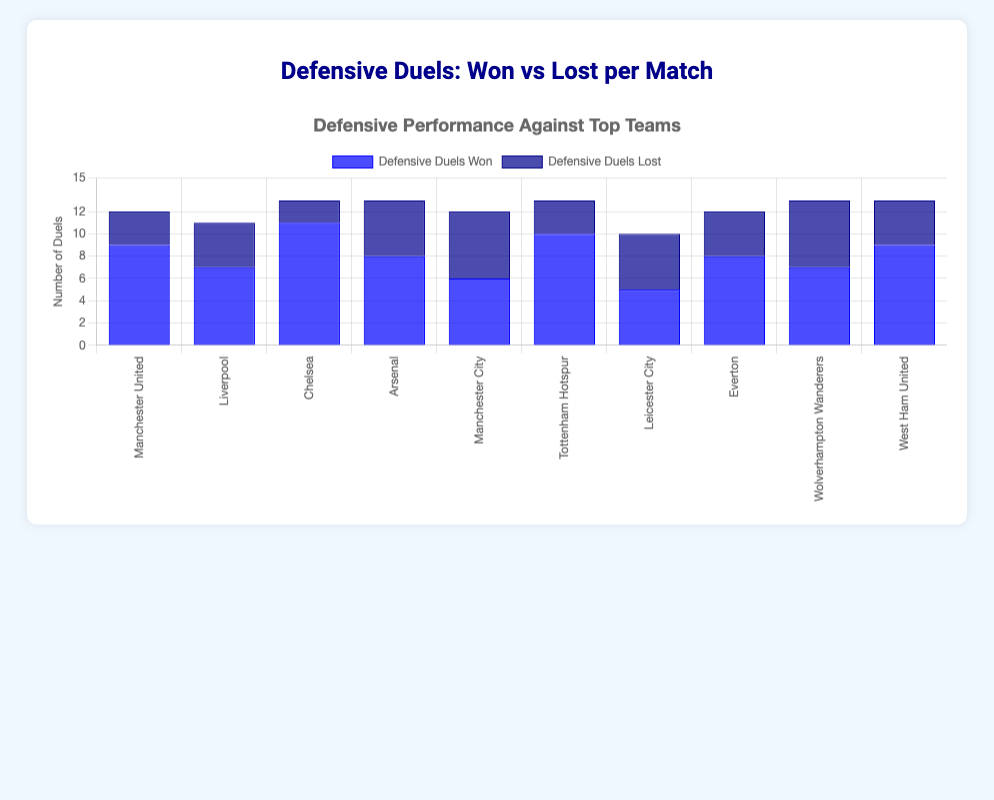Which match had the highest number of defensive duels won? By observing the height of the light blue bars representing the 'Defensive Duels Won' across all matches, the tallest bar indicates the highest number. The match against Chelsea has the highest bar.
Answer: Chelsea What is the total number of defensive duels lost across all matches? Sum the values of all the dark blue bars (representing 'Defensive Duels Lost'): 3 + 4 + 2 + 5 + 6 + 3 + 5 + 4 + 6 + 4 = 42.
Answer: 42 Which team had an equal number of defensive duels won and lost? Check the bars where the heights of dark blue and light blue bars are equal. This occurs for the match against Manchester City and Leicester City.
Answer: Manchester City, Leicester City How many more defensive duels were won than lost in the match against Arsenal? Identify the bars for Arsenal: 'Defensive Duels Won' is 8 and 'Defensive Duels Lost' is 5. Calculate the difference: 8 - 5 = 3.
Answer: 3 Which matches had more than 10 defensive duels in total? For each match, sum the 'Defensive Duels Won' and 'Defensive Duels Lost' and check if it exceeds 10: 
- Manchester United: 9 + 3 = 12
- Liverpool: 7 + 4 = 11
- Chelsea: 11 + 2 = 13
- Arsenal: 8 + 5 = 13
- Manchester City: 6 + 6 = 12
- Tottenham Hotspur: 10 + 3 = 13
- Leicester City: 5 + 5 = 10
- Everton: 8 + 4 = 12
- Wolverhampton Wanderers: 7 + 6 = 13
- West Ham United: 9 + 4 = 13
Matches with totals > 10 are: Manchester United, Liverpool, Chelsea, Arsenal, Manchester City, Tottenham Hotspur, Everton, Wolverhampton Wanderers, West Ham United.
Answer: Manchester United, Liverpool, Chelsea, Arsenal, Manchester City, Tottenham Hotspur, Everton, Wolverhampton Wanderers, West Ham United What is the average number of defensive duels won per match? Sum the 'Defensive Duels Won' values and divide by the number of matches: (9 + 7 + 11 + 8 + 6 + 10 + 5 + 8 + 7 + 9) / 10 = 80 / 10 = 8.
Answer: 8 